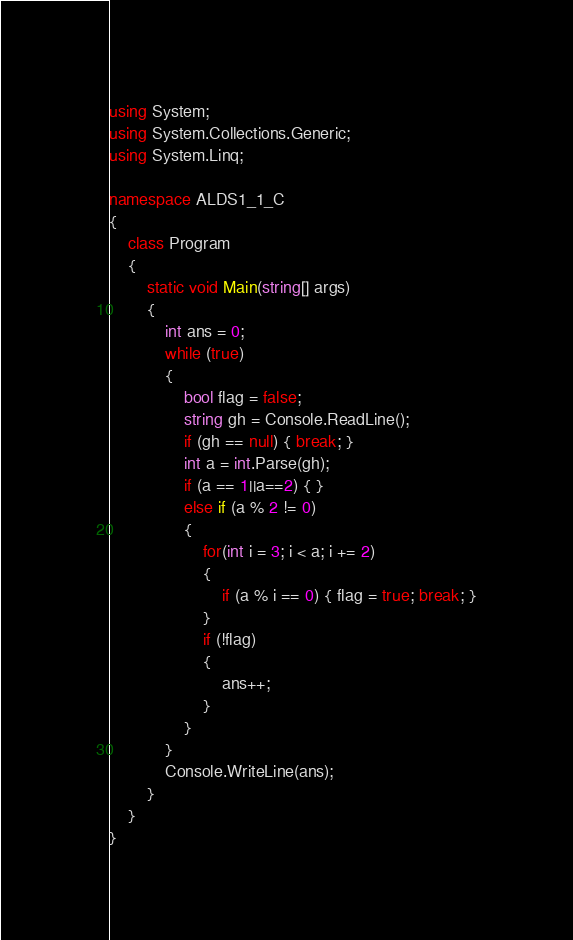<code> <loc_0><loc_0><loc_500><loc_500><_C#_>using System;
using System.Collections.Generic;
using System.Linq;

namespace ALDS1_1_C
{
    class Program
    {
        static void Main(string[] args)
        {
            int ans = 0;
            while (true)
            {
                bool flag = false;
                string gh = Console.ReadLine();
                if (gh == null) { break; }
                int a = int.Parse(gh);
                if (a == 1||a==2) { }
                else if (a % 2 != 0)                
                {
                    for(int i = 3; i < a; i += 2)
                    {
                        if (a % i == 0) { flag = true; break; }
                    }
                    if (!flag)
                    {
                        ans++;
                    }
                }
            }
            Console.WriteLine(ans);
        }
    }
}</code> 